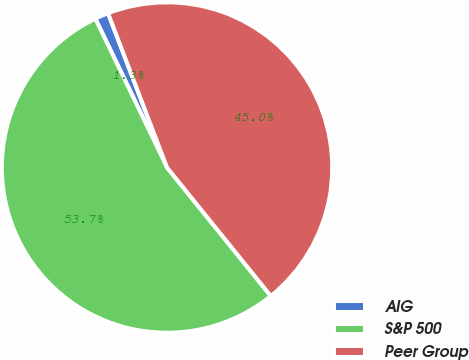<chart> <loc_0><loc_0><loc_500><loc_500><pie_chart><fcel>AIG<fcel>S&P 500<fcel>Peer Group<nl><fcel>1.33%<fcel>53.67%<fcel>45.0%<nl></chart> 